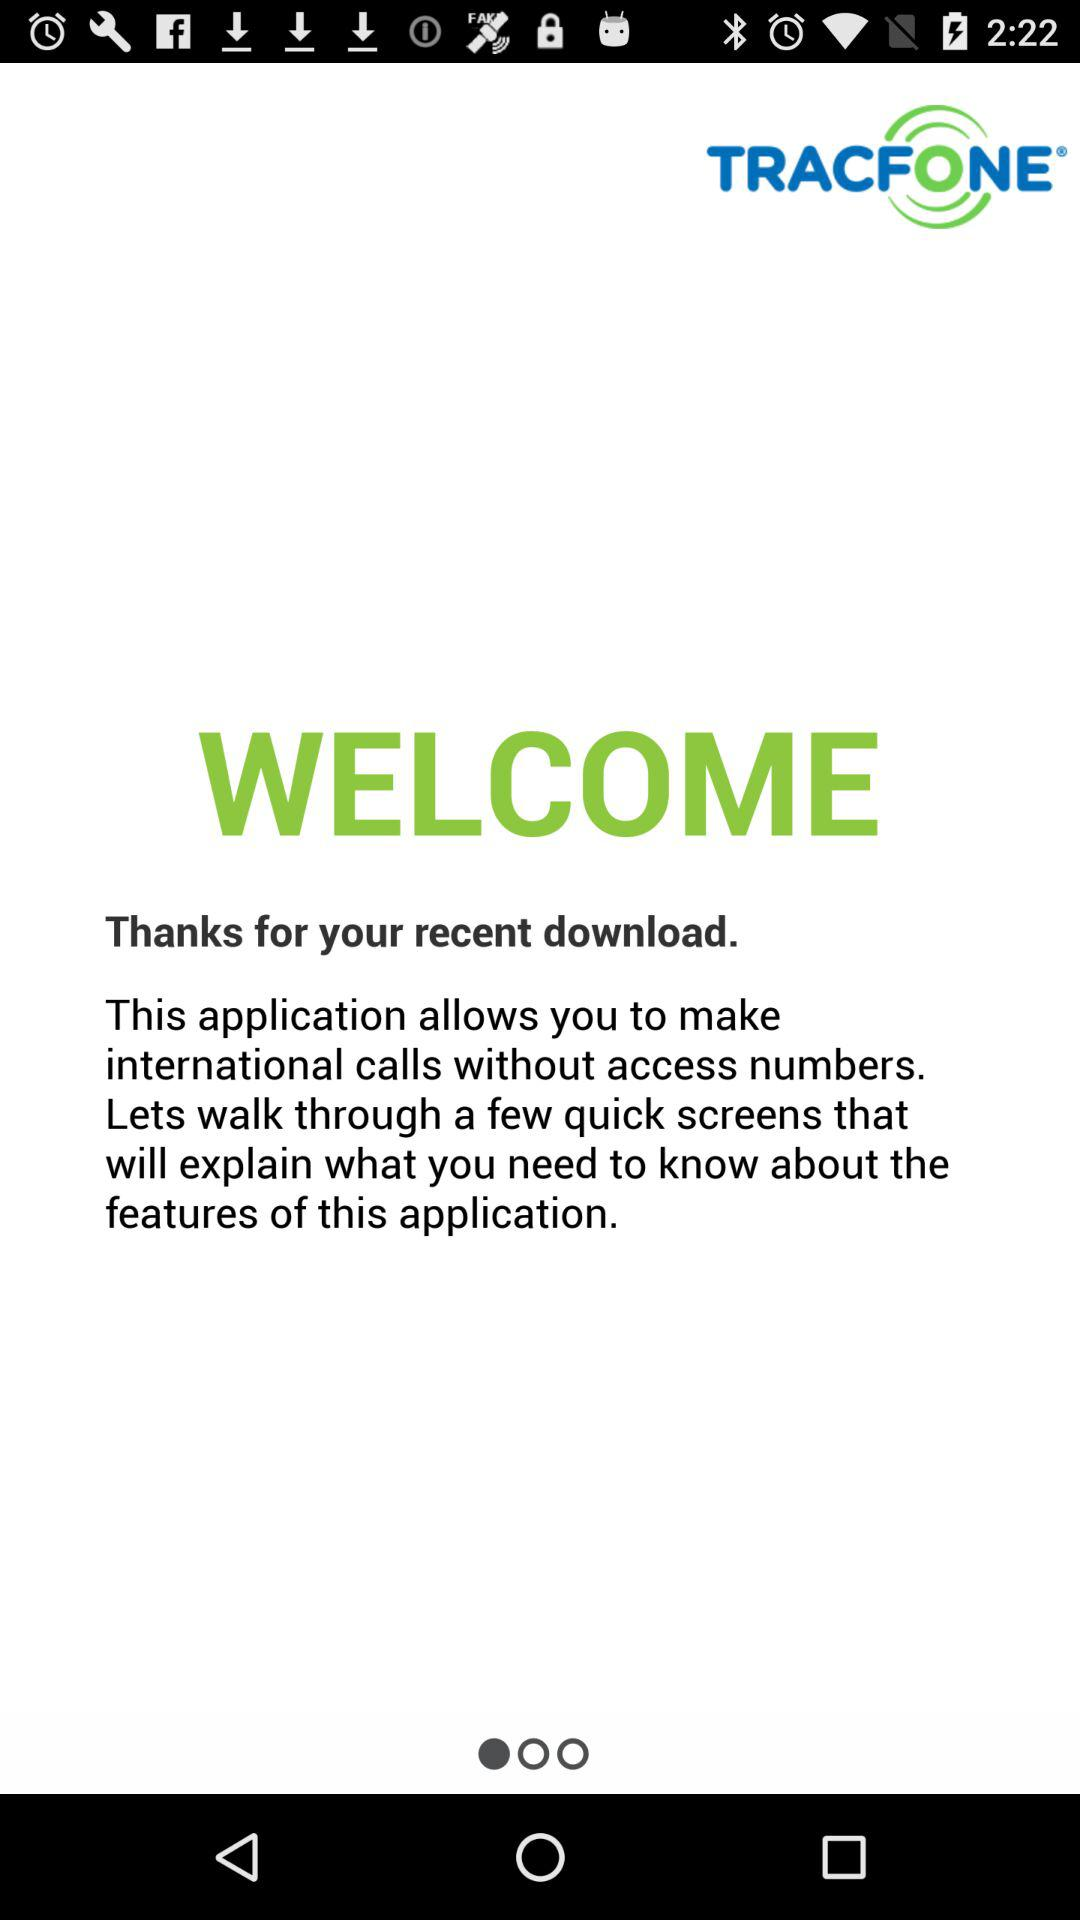What is the name of the application? The application name is "TRACFONE". 